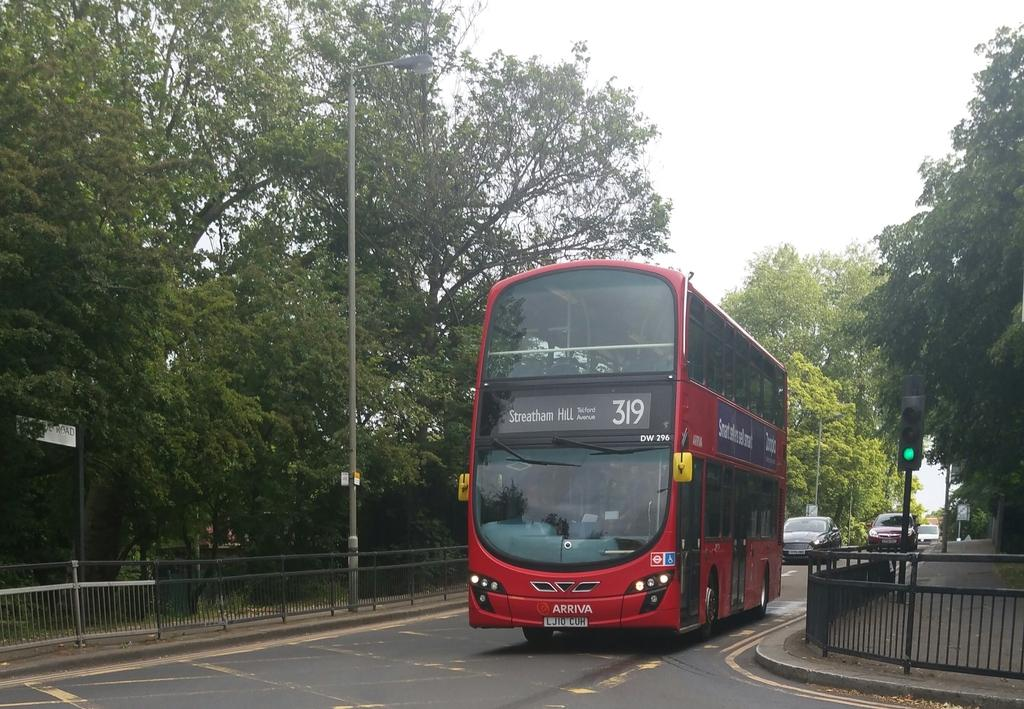What is the main feature of the image? There is a road in the image. What can be seen near the road? There is a railing near the road. What other objects are visible in the image? There are many poles and trees visible in the image. What is visible in the background of the image? The sky is visible in the background of the image. What type of paper is being used to cover the trees in the image? There is no paper present in the image, and the trees are not covered. Can you see a pickle on the road in the image? There is no pickle present in the image; it is a road with a railing, poles, trees, and a visible sky in the background. 